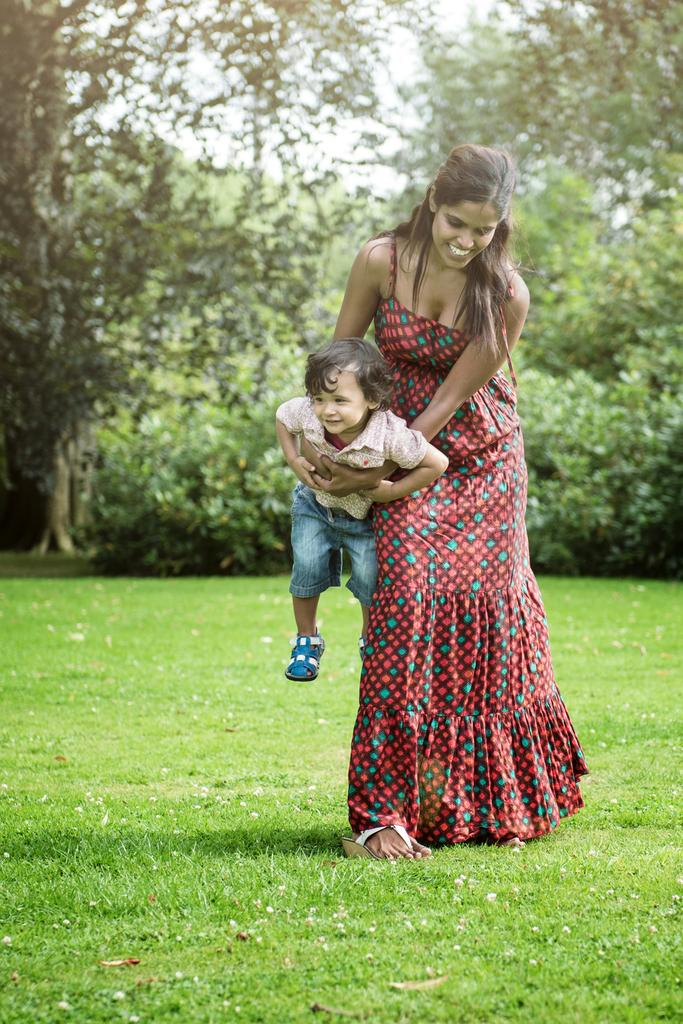What is the main subject of the image? There is a picture in the image. What is depicted in the picture? The picture contains a woman wearing a dress. What is the woman doing in the picture? The woman is holding a boy. What can be seen in the background of the image? There are trees in the background of the image. What emotion does the woman in the picture express when she discovers the disgusting surprise? There is no mention of any emotion or surprise in the image, as it only shows a woman holding a boy with trees in the background. 